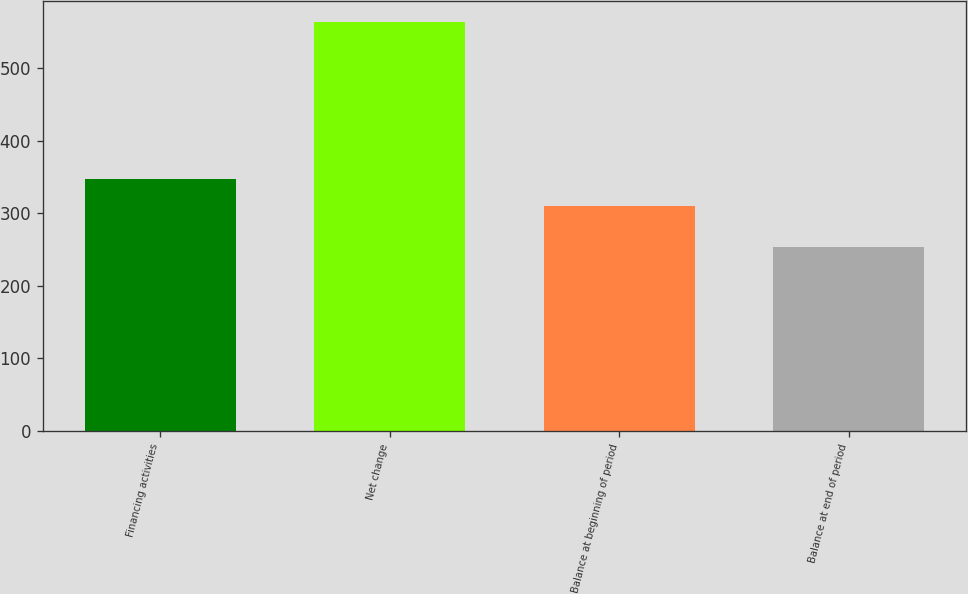Convert chart. <chart><loc_0><loc_0><loc_500><loc_500><bar_chart><fcel>Financing activities<fcel>Net change<fcel>Balance at beginning of period<fcel>Balance at end of period<nl><fcel>347<fcel>564<fcel>310<fcel>254<nl></chart> 